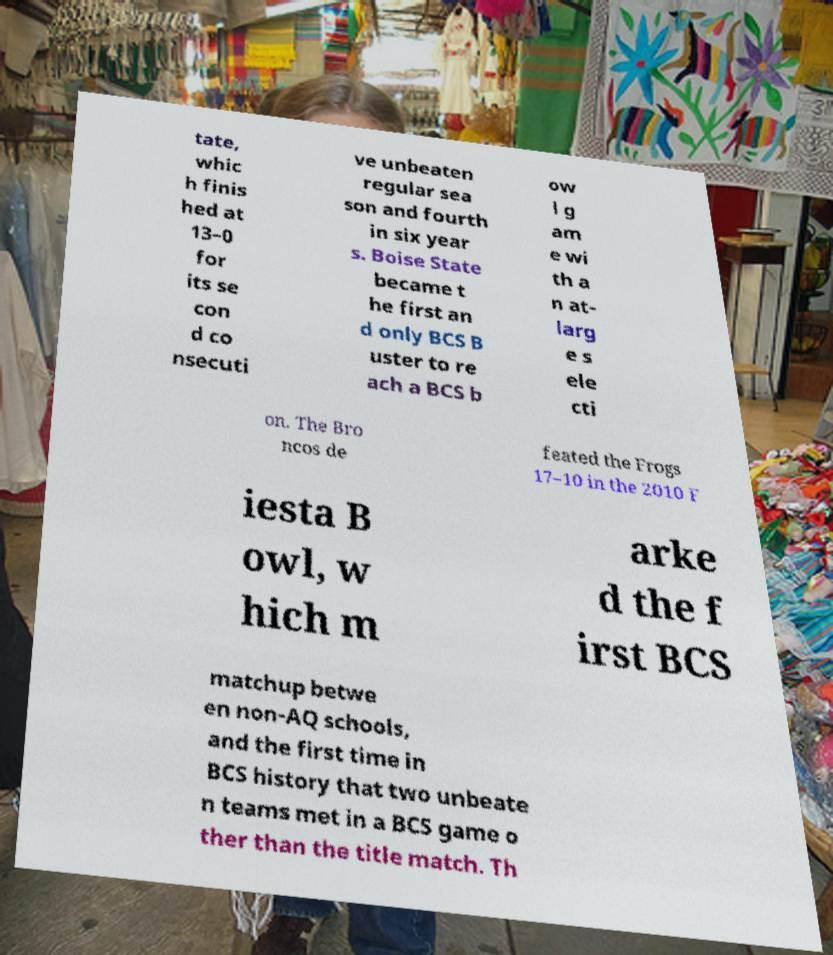Can you accurately transcribe the text from the provided image for me? tate, whic h finis hed at 13–0 for its se con d co nsecuti ve unbeaten regular sea son and fourth in six year s. Boise State became t he first an d only BCS B uster to re ach a BCS b ow l g am e wi th a n at- larg e s ele cti on. The Bro ncos de feated the Frogs 17–10 in the 2010 F iesta B owl, w hich m arke d the f irst BCS matchup betwe en non-AQ schools, and the first time in BCS history that two unbeate n teams met in a BCS game o ther than the title match. Th 